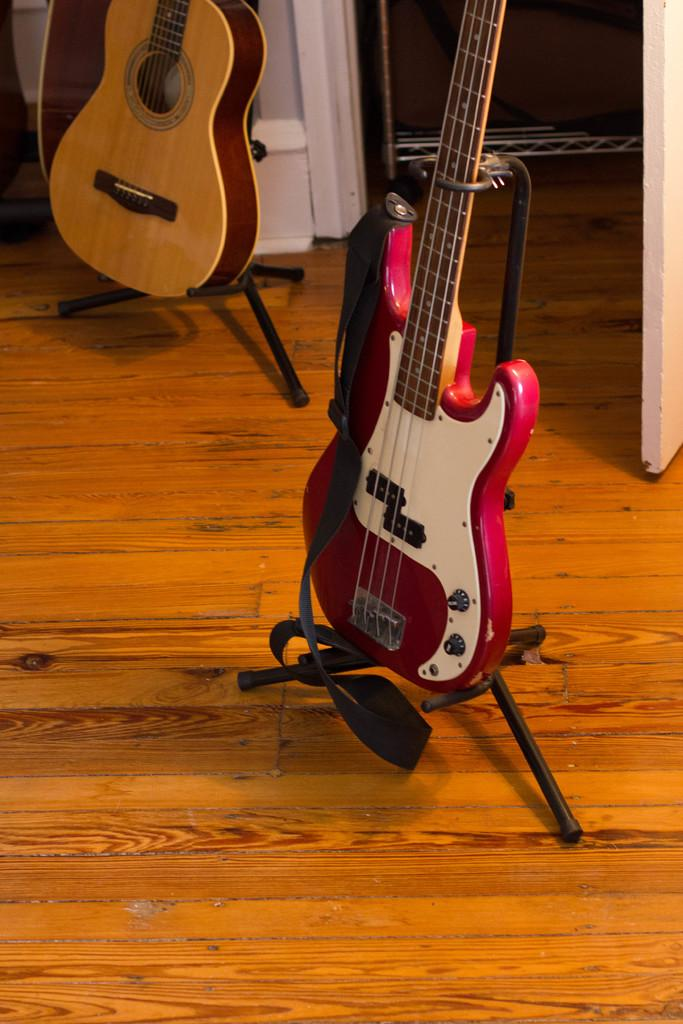What musical instruments are present in the image? There are two guitars in the image. How are the guitars positioned in the image? The guitars are kept in a stand. Where is the stand located in the image? The stand is on the floor. What type of coat is hanging on the guitars in the image? There is no coat present in the image; it only features two guitars in a stand on the floor. 